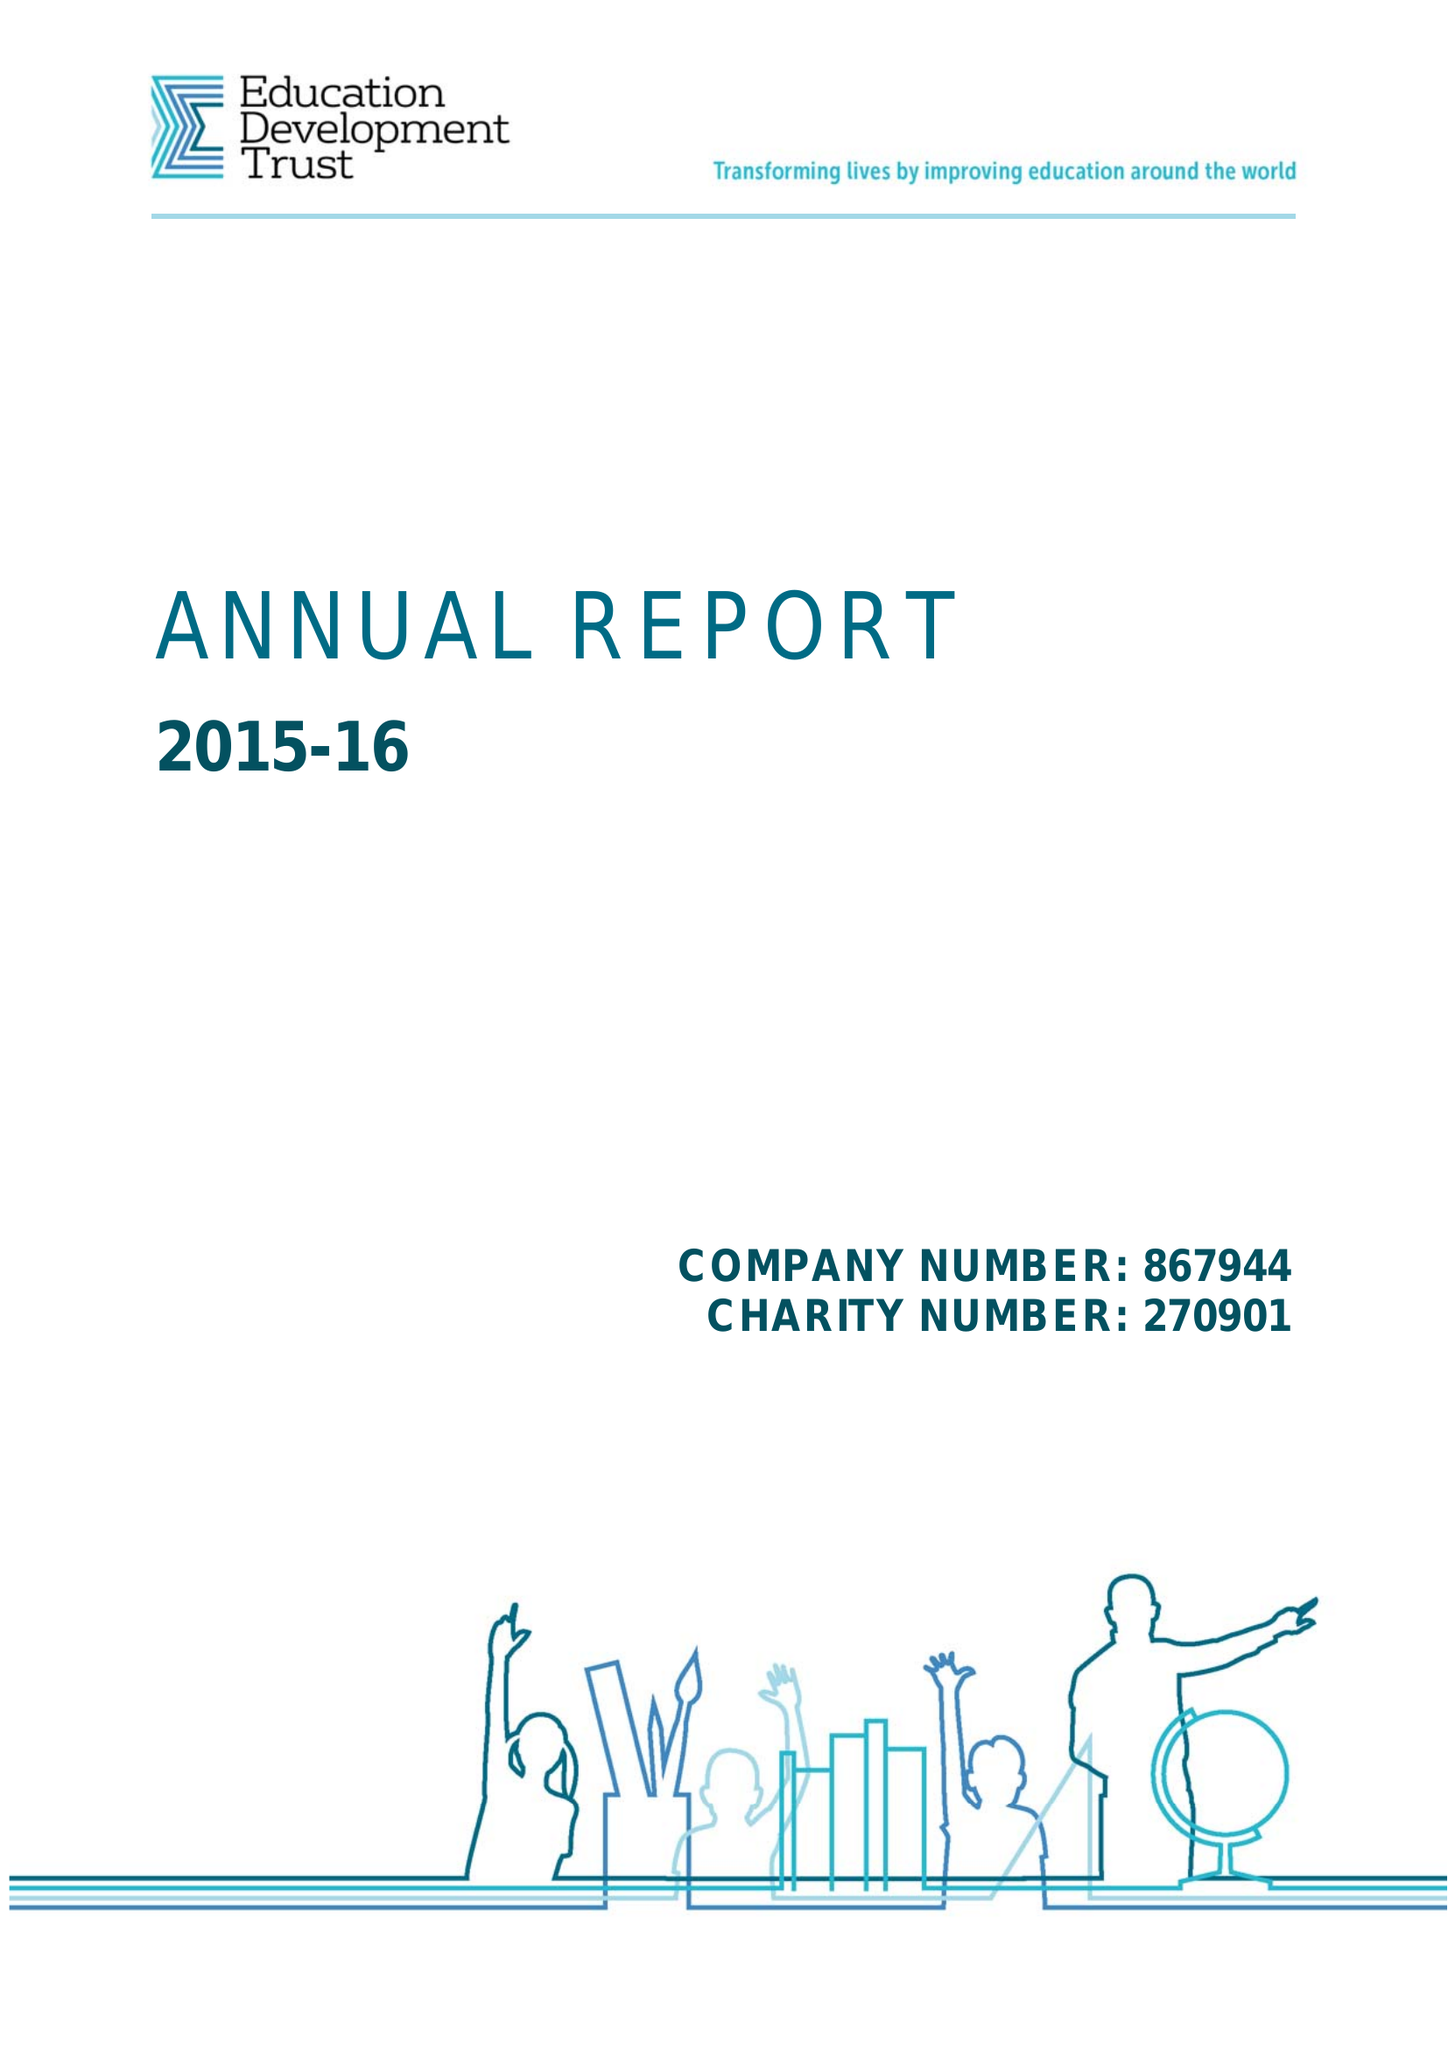What is the value for the address__street_line?
Answer the question using a single word or phrase. 16-18 DUKE STREET 